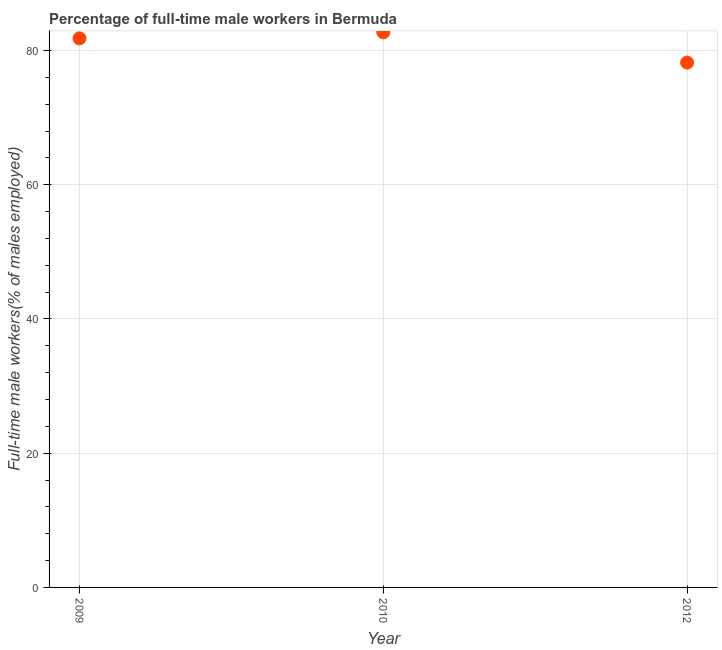What is the percentage of full-time male workers in 2012?
Your response must be concise. 78.2. Across all years, what is the maximum percentage of full-time male workers?
Offer a terse response. 82.7. Across all years, what is the minimum percentage of full-time male workers?
Make the answer very short. 78.2. In which year was the percentage of full-time male workers minimum?
Offer a very short reply. 2012. What is the sum of the percentage of full-time male workers?
Your answer should be compact. 242.7. What is the difference between the percentage of full-time male workers in 2010 and 2012?
Make the answer very short. 4.5. What is the average percentage of full-time male workers per year?
Keep it short and to the point. 80.9. What is the median percentage of full-time male workers?
Your answer should be compact. 81.8. What is the ratio of the percentage of full-time male workers in 2010 to that in 2012?
Offer a very short reply. 1.06. Is the percentage of full-time male workers in 2009 less than that in 2010?
Your answer should be very brief. Yes. Is the difference between the percentage of full-time male workers in 2009 and 2010 greater than the difference between any two years?
Ensure brevity in your answer.  No. What is the difference between the highest and the second highest percentage of full-time male workers?
Give a very brief answer. 0.9. Is the sum of the percentage of full-time male workers in 2010 and 2012 greater than the maximum percentage of full-time male workers across all years?
Provide a succinct answer. Yes. What is the difference between the highest and the lowest percentage of full-time male workers?
Ensure brevity in your answer.  4.5. In how many years, is the percentage of full-time male workers greater than the average percentage of full-time male workers taken over all years?
Your response must be concise. 2. How many dotlines are there?
Your response must be concise. 1. Does the graph contain any zero values?
Your answer should be compact. No. Does the graph contain grids?
Offer a terse response. Yes. What is the title of the graph?
Keep it short and to the point. Percentage of full-time male workers in Bermuda. What is the label or title of the Y-axis?
Make the answer very short. Full-time male workers(% of males employed). What is the Full-time male workers(% of males employed) in 2009?
Offer a very short reply. 81.8. What is the Full-time male workers(% of males employed) in 2010?
Ensure brevity in your answer.  82.7. What is the Full-time male workers(% of males employed) in 2012?
Keep it short and to the point. 78.2. What is the difference between the Full-time male workers(% of males employed) in 2009 and 2010?
Keep it short and to the point. -0.9. What is the difference between the Full-time male workers(% of males employed) in 2009 and 2012?
Your response must be concise. 3.6. What is the ratio of the Full-time male workers(% of males employed) in 2009 to that in 2010?
Offer a terse response. 0.99. What is the ratio of the Full-time male workers(% of males employed) in 2009 to that in 2012?
Provide a short and direct response. 1.05. What is the ratio of the Full-time male workers(% of males employed) in 2010 to that in 2012?
Your response must be concise. 1.06. 